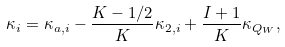<formula> <loc_0><loc_0><loc_500><loc_500>\kappa _ { i } = \kappa _ { a , i } - \frac { K - 1 / 2 } { K } \kappa _ { 2 , i } + \frac { I + 1 } { K } \kappa _ { Q _ { W } } ,</formula> 